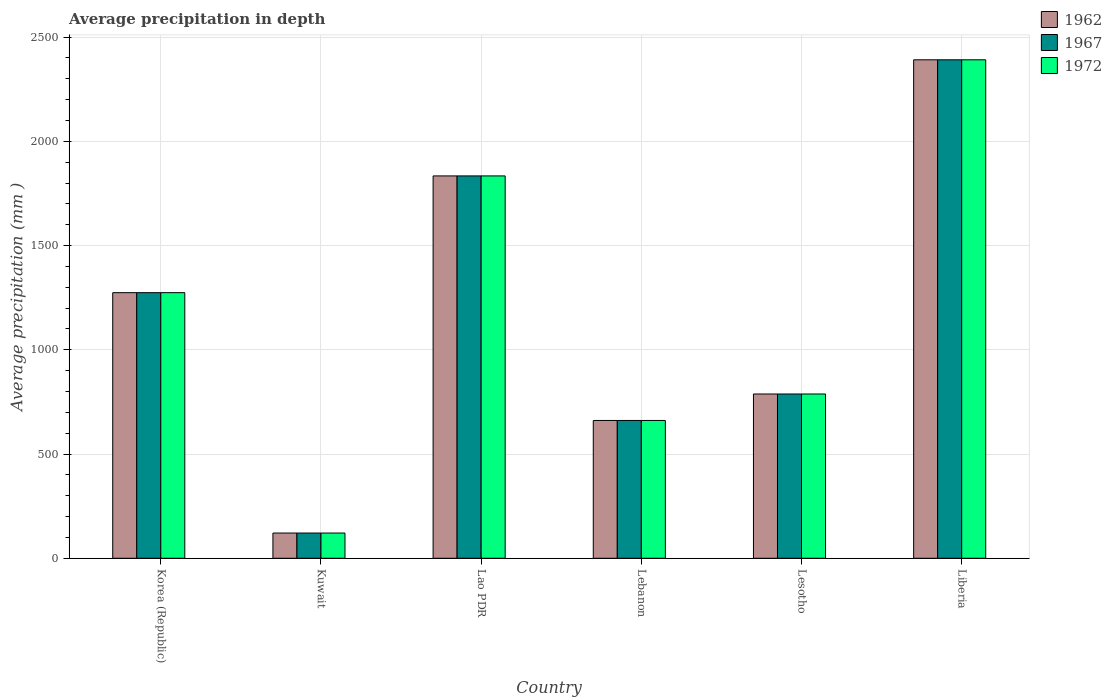How many groups of bars are there?
Your response must be concise. 6. How many bars are there on the 4th tick from the right?
Provide a succinct answer. 3. What is the label of the 2nd group of bars from the left?
Make the answer very short. Kuwait. What is the average precipitation in 1967 in Lesotho?
Your response must be concise. 788. Across all countries, what is the maximum average precipitation in 1972?
Offer a terse response. 2391. Across all countries, what is the minimum average precipitation in 1972?
Offer a very short reply. 121. In which country was the average precipitation in 1972 maximum?
Your answer should be very brief. Liberia. In which country was the average precipitation in 1972 minimum?
Provide a succinct answer. Kuwait. What is the total average precipitation in 1962 in the graph?
Provide a short and direct response. 7069. What is the difference between the average precipitation in 1972 in Lao PDR and that in Lesotho?
Offer a terse response. 1046. What is the difference between the average precipitation in 1962 in Lesotho and the average precipitation in 1967 in Kuwait?
Give a very brief answer. 667. What is the average average precipitation in 1972 per country?
Make the answer very short. 1178.17. What is the ratio of the average precipitation in 1967 in Kuwait to that in Liberia?
Offer a very short reply. 0.05. Is the average precipitation in 1972 in Kuwait less than that in Lesotho?
Your answer should be compact. Yes. What is the difference between the highest and the second highest average precipitation in 1962?
Ensure brevity in your answer.  560. What is the difference between the highest and the lowest average precipitation in 1967?
Provide a short and direct response. 2270. What does the 2nd bar from the left in Lao PDR represents?
Your answer should be very brief. 1967. Is it the case that in every country, the sum of the average precipitation in 1972 and average precipitation in 1967 is greater than the average precipitation in 1962?
Provide a short and direct response. Yes. How many bars are there?
Your response must be concise. 18. What is the difference between two consecutive major ticks on the Y-axis?
Provide a short and direct response. 500. Where does the legend appear in the graph?
Your response must be concise. Top right. How many legend labels are there?
Offer a terse response. 3. What is the title of the graph?
Your answer should be compact. Average precipitation in depth. Does "2006" appear as one of the legend labels in the graph?
Provide a short and direct response. No. What is the label or title of the X-axis?
Provide a succinct answer. Country. What is the label or title of the Y-axis?
Your answer should be compact. Average precipitation (mm ). What is the Average precipitation (mm ) in 1962 in Korea (Republic)?
Give a very brief answer. 1274. What is the Average precipitation (mm ) of 1967 in Korea (Republic)?
Your answer should be compact. 1274. What is the Average precipitation (mm ) of 1972 in Korea (Republic)?
Your answer should be compact. 1274. What is the Average precipitation (mm ) of 1962 in Kuwait?
Keep it short and to the point. 121. What is the Average precipitation (mm ) of 1967 in Kuwait?
Offer a terse response. 121. What is the Average precipitation (mm ) of 1972 in Kuwait?
Make the answer very short. 121. What is the Average precipitation (mm ) in 1962 in Lao PDR?
Make the answer very short. 1834. What is the Average precipitation (mm ) of 1967 in Lao PDR?
Provide a succinct answer. 1834. What is the Average precipitation (mm ) in 1972 in Lao PDR?
Offer a terse response. 1834. What is the Average precipitation (mm ) in 1962 in Lebanon?
Provide a succinct answer. 661. What is the Average precipitation (mm ) of 1967 in Lebanon?
Offer a terse response. 661. What is the Average precipitation (mm ) in 1972 in Lebanon?
Provide a succinct answer. 661. What is the Average precipitation (mm ) of 1962 in Lesotho?
Offer a very short reply. 788. What is the Average precipitation (mm ) of 1967 in Lesotho?
Your answer should be very brief. 788. What is the Average precipitation (mm ) of 1972 in Lesotho?
Provide a short and direct response. 788. What is the Average precipitation (mm ) in 1962 in Liberia?
Ensure brevity in your answer.  2391. What is the Average precipitation (mm ) of 1967 in Liberia?
Offer a very short reply. 2391. What is the Average precipitation (mm ) of 1972 in Liberia?
Offer a terse response. 2391. Across all countries, what is the maximum Average precipitation (mm ) in 1962?
Keep it short and to the point. 2391. Across all countries, what is the maximum Average precipitation (mm ) in 1967?
Offer a very short reply. 2391. Across all countries, what is the maximum Average precipitation (mm ) in 1972?
Provide a short and direct response. 2391. Across all countries, what is the minimum Average precipitation (mm ) of 1962?
Provide a succinct answer. 121. Across all countries, what is the minimum Average precipitation (mm ) of 1967?
Give a very brief answer. 121. Across all countries, what is the minimum Average precipitation (mm ) in 1972?
Provide a short and direct response. 121. What is the total Average precipitation (mm ) in 1962 in the graph?
Provide a short and direct response. 7069. What is the total Average precipitation (mm ) in 1967 in the graph?
Make the answer very short. 7069. What is the total Average precipitation (mm ) of 1972 in the graph?
Make the answer very short. 7069. What is the difference between the Average precipitation (mm ) in 1962 in Korea (Republic) and that in Kuwait?
Ensure brevity in your answer.  1153. What is the difference between the Average precipitation (mm ) of 1967 in Korea (Republic) and that in Kuwait?
Keep it short and to the point. 1153. What is the difference between the Average precipitation (mm ) of 1972 in Korea (Republic) and that in Kuwait?
Ensure brevity in your answer.  1153. What is the difference between the Average precipitation (mm ) in 1962 in Korea (Republic) and that in Lao PDR?
Your answer should be very brief. -560. What is the difference between the Average precipitation (mm ) of 1967 in Korea (Republic) and that in Lao PDR?
Your response must be concise. -560. What is the difference between the Average precipitation (mm ) of 1972 in Korea (Republic) and that in Lao PDR?
Ensure brevity in your answer.  -560. What is the difference between the Average precipitation (mm ) of 1962 in Korea (Republic) and that in Lebanon?
Provide a succinct answer. 613. What is the difference between the Average precipitation (mm ) of 1967 in Korea (Republic) and that in Lebanon?
Make the answer very short. 613. What is the difference between the Average precipitation (mm ) in 1972 in Korea (Republic) and that in Lebanon?
Your answer should be compact. 613. What is the difference between the Average precipitation (mm ) in 1962 in Korea (Republic) and that in Lesotho?
Ensure brevity in your answer.  486. What is the difference between the Average precipitation (mm ) of 1967 in Korea (Republic) and that in Lesotho?
Offer a very short reply. 486. What is the difference between the Average precipitation (mm ) in 1972 in Korea (Republic) and that in Lesotho?
Your answer should be very brief. 486. What is the difference between the Average precipitation (mm ) in 1962 in Korea (Republic) and that in Liberia?
Your answer should be compact. -1117. What is the difference between the Average precipitation (mm ) of 1967 in Korea (Republic) and that in Liberia?
Your answer should be very brief. -1117. What is the difference between the Average precipitation (mm ) in 1972 in Korea (Republic) and that in Liberia?
Your response must be concise. -1117. What is the difference between the Average precipitation (mm ) in 1962 in Kuwait and that in Lao PDR?
Your answer should be compact. -1713. What is the difference between the Average precipitation (mm ) of 1967 in Kuwait and that in Lao PDR?
Ensure brevity in your answer.  -1713. What is the difference between the Average precipitation (mm ) in 1972 in Kuwait and that in Lao PDR?
Make the answer very short. -1713. What is the difference between the Average precipitation (mm ) of 1962 in Kuwait and that in Lebanon?
Keep it short and to the point. -540. What is the difference between the Average precipitation (mm ) in 1967 in Kuwait and that in Lebanon?
Offer a terse response. -540. What is the difference between the Average precipitation (mm ) of 1972 in Kuwait and that in Lebanon?
Make the answer very short. -540. What is the difference between the Average precipitation (mm ) in 1962 in Kuwait and that in Lesotho?
Offer a very short reply. -667. What is the difference between the Average precipitation (mm ) in 1967 in Kuwait and that in Lesotho?
Your response must be concise. -667. What is the difference between the Average precipitation (mm ) of 1972 in Kuwait and that in Lesotho?
Keep it short and to the point. -667. What is the difference between the Average precipitation (mm ) in 1962 in Kuwait and that in Liberia?
Keep it short and to the point. -2270. What is the difference between the Average precipitation (mm ) in 1967 in Kuwait and that in Liberia?
Offer a terse response. -2270. What is the difference between the Average precipitation (mm ) of 1972 in Kuwait and that in Liberia?
Your answer should be compact. -2270. What is the difference between the Average precipitation (mm ) in 1962 in Lao PDR and that in Lebanon?
Your answer should be very brief. 1173. What is the difference between the Average precipitation (mm ) of 1967 in Lao PDR and that in Lebanon?
Provide a short and direct response. 1173. What is the difference between the Average precipitation (mm ) of 1972 in Lao PDR and that in Lebanon?
Give a very brief answer. 1173. What is the difference between the Average precipitation (mm ) in 1962 in Lao PDR and that in Lesotho?
Your response must be concise. 1046. What is the difference between the Average precipitation (mm ) of 1967 in Lao PDR and that in Lesotho?
Provide a succinct answer. 1046. What is the difference between the Average precipitation (mm ) of 1972 in Lao PDR and that in Lesotho?
Give a very brief answer. 1046. What is the difference between the Average precipitation (mm ) of 1962 in Lao PDR and that in Liberia?
Keep it short and to the point. -557. What is the difference between the Average precipitation (mm ) of 1967 in Lao PDR and that in Liberia?
Provide a short and direct response. -557. What is the difference between the Average precipitation (mm ) of 1972 in Lao PDR and that in Liberia?
Make the answer very short. -557. What is the difference between the Average precipitation (mm ) in 1962 in Lebanon and that in Lesotho?
Provide a short and direct response. -127. What is the difference between the Average precipitation (mm ) in 1967 in Lebanon and that in Lesotho?
Make the answer very short. -127. What is the difference between the Average precipitation (mm ) in 1972 in Lebanon and that in Lesotho?
Keep it short and to the point. -127. What is the difference between the Average precipitation (mm ) in 1962 in Lebanon and that in Liberia?
Provide a short and direct response. -1730. What is the difference between the Average precipitation (mm ) of 1967 in Lebanon and that in Liberia?
Give a very brief answer. -1730. What is the difference between the Average precipitation (mm ) of 1972 in Lebanon and that in Liberia?
Keep it short and to the point. -1730. What is the difference between the Average precipitation (mm ) in 1962 in Lesotho and that in Liberia?
Provide a succinct answer. -1603. What is the difference between the Average precipitation (mm ) in 1967 in Lesotho and that in Liberia?
Your answer should be very brief. -1603. What is the difference between the Average precipitation (mm ) in 1972 in Lesotho and that in Liberia?
Offer a very short reply. -1603. What is the difference between the Average precipitation (mm ) of 1962 in Korea (Republic) and the Average precipitation (mm ) of 1967 in Kuwait?
Your answer should be compact. 1153. What is the difference between the Average precipitation (mm ) in 1962 in Korea (Republic) and the Average precipitation (mm ) in 1972 in Kuwait?
Ensure brevity in your answer.  1153. What is the difference between the Average precipitation (mm ) of 1967 in Korea (Republic) and the Average precipitation (mm ) of 1972 in Kuwait?
Make the answer very short. 1153. What is the difference between the Average precipitation (mm ) in 1962 in Korea (Republic) and the Average precipitation (mm ) in 1967 in Lao PDR?
Your response must be concise. -560. What is the difference between the Average precipitation (mm ) in 1962 in Korea (Republic) and the Average precipitation (mm ) in 1972 in Lao PDR?
Provide a short and direct response. -560. What is the difference between the Average precipitation (mm ) in 1967 in Korea (Republic) and the Average precipitation (mm ) in 1972 in Lao PDR?
Give a very brief answer. -560. What is the difference between the Average precipitation (mm ) of 1962 in Korea (Republic) and the Average precipitation (mm ) of 1967 in Lebanon?
Keep it short and to the point. 613. What is the difference between the Average precipitation (mm ) of 1962 in Korea (Republic) and the Average precipitation (mm ) of 1972 in Lebanon?
Keep it short and to the point. 613. What is the difference between the Average precipitation (mm ) of 1967 in Korea (Republic) and the Average precipitation (mm ) of 1972 in Lebanon?
Give a very brief answer. 613. What is the difference between the Average precipitation (mm ) in 1962 in Korea (Republic) and the Average precipitation (mm ) in 1967 in Lesotho?
Offer a terse response. 486. What is the difference between the Average precipitation (mm ) in 1962 in Korea (Republic) and the Average precipitation (mm ) in 1972 in Lesotho?
Offer a terse response. 486. What is the difference between the Average precipitation (mm ) of 1967 in Korea (Republic) and the Average precipitation (mm ) of 1972 in Lesotho?
Your answer should be compact. 486. What is the difference between the Average precipitation (mm ) of 1962 in Korea (Republic) and the Average precipitation (mm ) of 1967 in Liberia?
Provide a short and direct response. -1117. What is the difference between the Average precipitation (mm ) of 1962 in Korea (Republic) and the Average precipitation (mm ) of 1972 in Liberia?
Keep it short and to the point. -1117. What is the difference between the Average precipitation (mm ) in 1967 in Korea (Republic) and the Average precipitation (mm ) in 1972 in Liberia?
Make the answer very short. -1117. What is the difference between the Average precipitation (mm ) of 1962 in Kuwait and the Average precipitation (mm ) of 1967 in Lao PDR?
Offer a terse response. -1713. What is the difference between the Average precipitation (mm ) of 1962 in Kuwait and the Average precipitation (mm ) of 1972 in Lao PDR?
Offer a very short reply. -1713. What is the difference between the Average precipitation (mm ) in 1967 in Kuwait and the Average precipitation (mm ) in 1972 in Lao PDR?
Your answer should be compact. -1713. What is the difference between the Average precipitation (mm ) of 1962 in Kuwait and the Average precipitation (mm ) of 1967 in Lebanon?
Offer a terse response. -540. What is the difference between the Average precipitation (mm ) in 1962 in Kuwait and the Average precipitation (mm ) in 1972 in Lebanon?
Give a very brief answer. -540. What is the difference between the Average precipitation (mm ) of 1967 in Kuwait and the Average precipitation (mm ) of 1972 in Lebanon?
Your response must be concise. -540. What is the difference between the Average precipitation (mm ) of 1962 in Kuwait and the Average precipitation (mm ) of 1967 in Lesotho?
Your answer should be compact. -667. What is the difference between the Average precipitation (mm ) of 1962 in Kuwait and the Average precipitation (mm ) of 1972 in Lesotho?
Make the answer very short. -667. What is the difference between the Average precipitation (mm ) in 1967 in Kuwait and the Average precipitation (mm ) in 1972 in Lesotho?
Keep it short and to the point. -667. What is the difference between the Average precipitation (mm ) of 1962 in Kuwait and the Average precipitation (mm ) of 1967 in Liberia?
Offer a terse response. -2270. What is the difference between the Average precipitation (mm ) of 1962 in Kuwait and the Average precipitation (mm ) of 1972 in Liberia?
Make the answer very short. -2270. What is the difference between the Average precipitation (mm ) of 1967 in Kuwait and the Average precipitation (mm ) of 1972 in Liberia?
Keep it short and to the point. -2270. What is the difference between the Average precipitation (mm ) of 1962 in Lao PDR and the Average precipitation (mm ) of 1967 in Lebanon?
Provide a short and direct response. 1173. What is the difference between the Average precipitation (mm ) in 1962 in Lao PDR and the Average precipitation (mm ) in 1972 in Lebanon?
Give a very brief answer. 1173. What is the difference between the Average precipitation (mm ) in 1967 in Lao PDR and the Average precipitation (mm ) in 1972 in Lebanon?
Keep it short and to the point. 1173. What is the difference between the Average precipitation (mm ) of 1962 in Lao PDR and the Average precipitation (mm ) of 1967 in Lesotho?
Make the answer very short. 1046. What is the difference between the Average precipitation (mm ) in 1962 in Lao PDR and the Average precipitation (mm ) in 1972 in Lesotho?
Offer a terse response. 1046. What is the difference between the Average precipitation (mm ) in 1967 in Lao PDR and the Average precipitation (mm ) in 1972 in Lesotho?
Provide a succinct answer. 1046. What is the difference between the Average precipitation (mm ) in 1962 in Lao PDR and the Average precipitation (mm ) in 1967 in Liberia?
Provide a succinct answer. -557. What is the difference between the Average precipitation (mm ) in 1962 in Lao PDR and the Average precipitation (mm ) in 1972 in Liberia?
Your answer should be compact. -557. What is the difference between the Average precipitation (mm ) in 1967 in Lao PDR and the Average precipitation (mm ) in 1972 in Liberia?
Your response must be concise. -557. What is the difference between the Average precipitation (mm ) of 1962 in Lebanon and the Average precipitation (mm ) of 1967 in Lesotho?
Offer a very short reply. -127. What is the difference between the Average precipitation (mm ) of 1962 in Lebanon and the Average precipitation (mm ) of 1972 in Lesotho?
Offer a terse response. -127. What is the difference between the Average precipitation (mm ) in 1967 in Lebanon and the Average precipitation (mm ) in 1972 in Lesotho?
Keep it short and to the point. -127. What is the difference between the Average precipitation (mm ) of 1962 in Lebanon and the Average precipitation (mm ) of 1967 in Liberia?
Your answer should be compact. -1730. What is the difference between the Average precipitation (mm ) in 1962 in Lebanon and the Average precipitation (mm ) in 1972 in Liberia?
Your answer should be very brief. -1730. What is the difference between the Average precipitation (mm ) of 1967 in Lebanon and the Average precipitation (mm ) of 1972 in Liberia?
Ensure brevity in your answer.  -1730. What is the difference between the Average precipitation (mm ) of 1962 in Lesotho and the Average precipitation (mm ) of 1967 in Liberia?
Provide a succinct answer. -1603. What is the difference between the Average precipitation (mm ) of 1962 in Lesotho and the Average precipitation (mm ) of 1972 in Liberia?
Keep it short and to the point. -1603. What is the difference between the Average precipitation (mm ) in 1967 in Lesotho and the Average precipitation (mm ) in 1972 in Liberia?
Provide a short and direct response. -1603. What is the average Average precipitation (mm ) in 1962 per country?
Provide a short and direct response. 1178.17. What is the average Average precipitation (mm ) of 1967 per country?
Provide a short and direct response. 1178.17. What is the average Average precipitation (mm ) in 1972 per country?
Give a very brief answer. 1178.17. What is the difference between the Average precipitation (mm ) of 1962 and Average precipitation (mm ) of 1972 in Korea (Republic)?
Make the answer very short. 0. What is the difference between the Average precipitation (mm ) in 1962 and Average precipitation (mm ) in 1967 in Kuwait?
Your response must be concise. 0. What is the difference between the Average precipitation (mm ) in 1967 and Average precipitation (mm ) in 1972 in Kuwait?
Your answer should be compact. 0. What is the difference between the Average precipitation (mm ) of 1962 and Average precipitation (mm ) of 1967 in Lao PDR?
Provide a succinct answer. 0. What is the difference between the Average precipitation (mm ) of 1962 and Average precipitation (mm ) of 1972 in Lao PDR?
Give a very brief answer. 0. What is the difference between the Average precipitation (mm ) in 1962 and Average precipitation (mm ) in 1972 in Lebanon?
Your answer should be very brief. 0. What is the difference between the Average precipitation (mm ) in 1967 and Average precipitation (mm ) in 1972 in Lebanon?
Your answer should be compact. 0. What is the difference between the Average precipitation (mm ) in 1967 and Average precipitation (mm ) in 1972 in Lesotho?
Offer a terse response. 0. What is the difference between the Average precipitation (mm ) of 1962 and Average precipitation (mm ) of 1967 in Liberia?
Offer a very short reply. 0. What is the difference between the Average precipitation (mm ) of 1967 and Average precipitation (mm ) of 1972 in Liberia?
Provide a short and direct response. 0. What is the ratio of the Average precipitation (mm ) of 1962 in Korea (Republic) to that in Kuwait?
Keep it short and to the point. 10.53. What is the ratio of the Average precipitation (mm ) in 1967 in Korea (Republic) to that in Kuwait?
Offer a very short reply. 10.53. What is the ratio of the Average precipitation (mm ) in 1972 in Korea (Republic) to that in Kuwait?
Keep it short and to the point. 10.53. What is the ratio of the Average precipitation (mm ) in 1962 in Korea (Republic) to that in Lao PDR?
Provide a short and direct response. 0.69. What is the ratio of the Average precipitation (mm ) in 1967 in Korea (Republic) to that in Lao PDR?
Your response must be concise. 0.69. What is the ratio of the Average precipitation (mm ) of 1972 in Korea (Republic) to that in Lao PDR?
Provide a succinct answer. 0.69. What is the ratio of the Average precipitation (mm ) in 1962 in Korea (Republic) to that in Lebanon?
Your answer should be very brief. 1.93. What is the ratio of the Average precipitation (mm ) of 1967 in Korea (Republic) to that in Lebanon?
Make the answer very short. 1.93. What is the ratio of the Average precipitation (mm ) in 1972 in Korea (Republic) to that in Lebanon?
Provide a short and direct response. 1.93. What is the ratio of the Average precipitation (mm ) of 1962 in Korea (Republic) to that in Lesotho?
Provide a short and direct response. 1.62. What is the ratio of the Average precipitation (mm ) of 1967 in Korea (Republic) to that in Lesotho?
Ensure brevity in your answer.  1.62. What is the ratio of the Average precipitation (mm ) of 1972 in Korea (Republic) to that in Lesotho?
Make the answer very short. 1.62. What is the ratio of the Average precipitation (mm ) of 1962 in Korea (Republic) to that in Liberia?
Provide a short and direct response. 0.53. What is the ratio of the Average precipitation (mm ) in 1967 in Korea (Republic) to that in Liberia?
Make the answer very short. 0.53. What is the ratio of the Average precipitation (mm ) of 1972 in Korea (Republic) to that in Liberia?
Your answer should be very brief. 0.53. What is the ratio of the Average precipitation (mm ) in 1962 in Kuwait to that in Lao PDR?
Your answer should be compact. 0.07. What is the ratio of the Average precipitation (mm ) of 1967 in Kuwait to that in Lao PDR?
Keep it short and to the point. 0.07. What is the ratio of the Average precipitation (mm ) of 1972 in Kuwait to that in Lao PDR?
Your answer should be compact. 0.07. What is the ratio of the Average precipitation (mm ) in 1962 in Kuwait to that in Lebanon?
Keep it short and to the point. 0.18. What is the ratio of the Average precipitation (mm ) in 1967 in Kuwait to that in Lebanon?
Your response must be concise. 0.18. What is the ratio of the Average precipitation (mm ) of 1972 in Kuwait to that in Lebanon?
Offer a terse response. 0.18. What is the ratio of the Average precipitation (mm ) of 1962 in Kuwait to that in Lesotho?
Keep it short and to the point. 0.15. What is the ratio of the Average precipitation (mm ) of 1967 in Kuwait to that in Lesotho?
Keep it short and to the point. 0.15. What is the ratio of the Average precipitation (mm ) of 1972 in Kuwait to that in Lesotho?
Your response must be concise. 0.15. What is the ratio of the Average precipitation (mm ) in 1962 in Kuwait to that in Liberia?
Your answer should be compact. 0.05. What is the ratio of the Average precipitation (mm ) of 1967 in Kuwait to that in Liberia?
Your answer should be very brief. 0.05. What is the ratio of the Average precipitation (mm ) of 1972 in Kuwait to that in Liberia?
Offer a terse response. 0.05. What is the ratio of the Average precipitation (mm ) of 1962 in Lao PDR to that in Lebanon?
Your answer should be very brief. 2.77. What is the ratio of the Average precipitation (mm ) in 1967 in Lao PDR to that in Lebanon?
Give a very brief answer. 2.77. What is the ratio of the Average precipitation (mm ) of 1972 in Lao PDR to that in Lebanon?
Your answer should be compact. 2.77. What is the ratio of the Average precipitation (mm ) of 1962 in Lao PDR to that in Lesotho?
Ensure brevity in your answer.  2.33. What is the ratio of the Average precipitation (mm ) of 1967 in Lao PDR to that in Lesotho?
Your answer should be very brief. 2.33. What is the ratio of the Average precipitation (mm ) in 1972 in Lao PDR to that in Lesotho?
Provide a succinct answer. 2.33. What is the ratio of the Average precipitation (mm ) in 1962 in Lao PDR to that in Liberia?
Provide a succinct answer. 0.77. What is the ratio of the Average precipitation (mm ) of 1967 in Lao PDR to that in Liberia?
Keep it short and to the point. 0.77. What is the ratio of the Average precipitation (mm ) of 1972 in Lao PDR to that in Liberia?
Your answer should be very brief. 0.77. What is the ratio of the Average precipitation (mm ) in 1962 in Lebanon to that in Lesotho?
Your response must be concise. 0.84. What is the ratio of the Average precipitation (mm ) in 1967 in Lebanon to that in Lesotho?
Make the answer very short. 0.84. What is the ratio of the Average precipitation (mm ) of 1972 in Lebanon to that in Lesotho?
Offer a very short reply. 0.84. What is the ratio of the Average precipitation (mm ) in 1962 in Lebanon to that in Liberia?
Provide a short and direct response. 0.28. What is the ratio of the Average precipitation (mm ) of 1967 in Lebanon to that in Liberia?
Offer a terse response. 0.28. What is the ratio of the Average precipitation (mm ) of 1972 in Lebanon to that in Liberia?
Your answer should be compact. 0.28. What is the ratio of the Average precipitation (mm ) of 1962 in Lesotho to that in Liberia?
Provide a succinct answer. 0.33. What is the ratio of the Average precipitation (mm ) in 1967 in Lesotho to that in Liberia?
Provide a succinct answer. 0.33. What is the ratio of the Average precipitation (mm ) in 1972 in Lesotho to that in Liberia?
Your response must be concise. 0.33. What is the difference between the highest and the second highest Average precipitation (mm ) in 1962?
Offer a very short reply. 557. What is the difference between the highest and the second highest Average precipitation (mm ) in 1967?
Provide a succinct answer. 557. What is the difference between the highest and the second highest Average precipitation (mm ) of 1972?
Your answer should be compact. 557. What is the difference between the highest and the lowest Average precipitation (mm ) of 1962?
Offer a very short reply. 2270. What is the difference between the highest and the lowest Average precipitation (mm ) in 1967?
Provide a short and direct response. 2270. What is the difference between the highest and the lowest Average precipitation (mm ) of 1972?
Offer a terse response. 2270. 